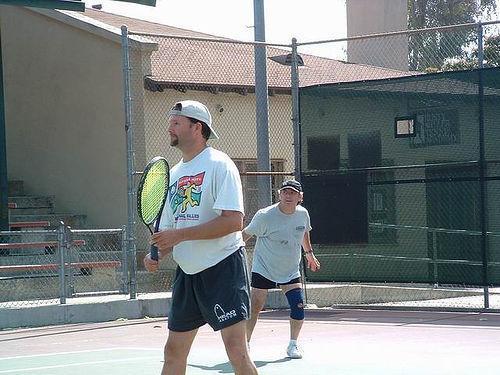How many hats are being worn backwards?
Give a very brief answer. 1. How many people are in the photo?
Give a very brief answer. 2. How many orange ropescables are attached to the clock?
Give a very brief answer. 0. 